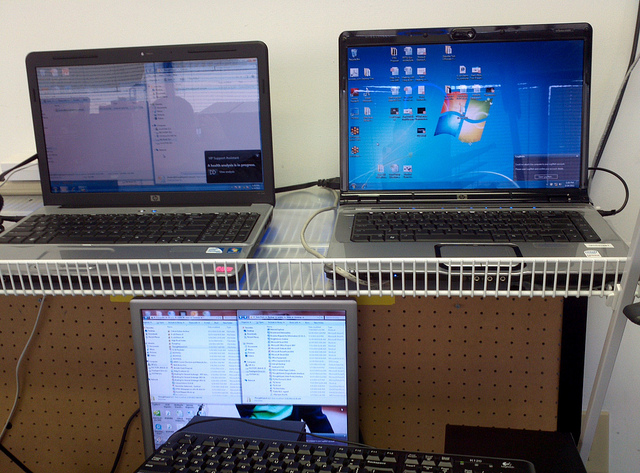What do the different wallpapers tell us? The varied wallpapers may reflect personalization or serve as a visual cue to easily distinguish between different tasks or projects. Each wallpaper can act as a subconscious signal to the user, helping them quickly switch mental contexts when looking at a particular screen. 